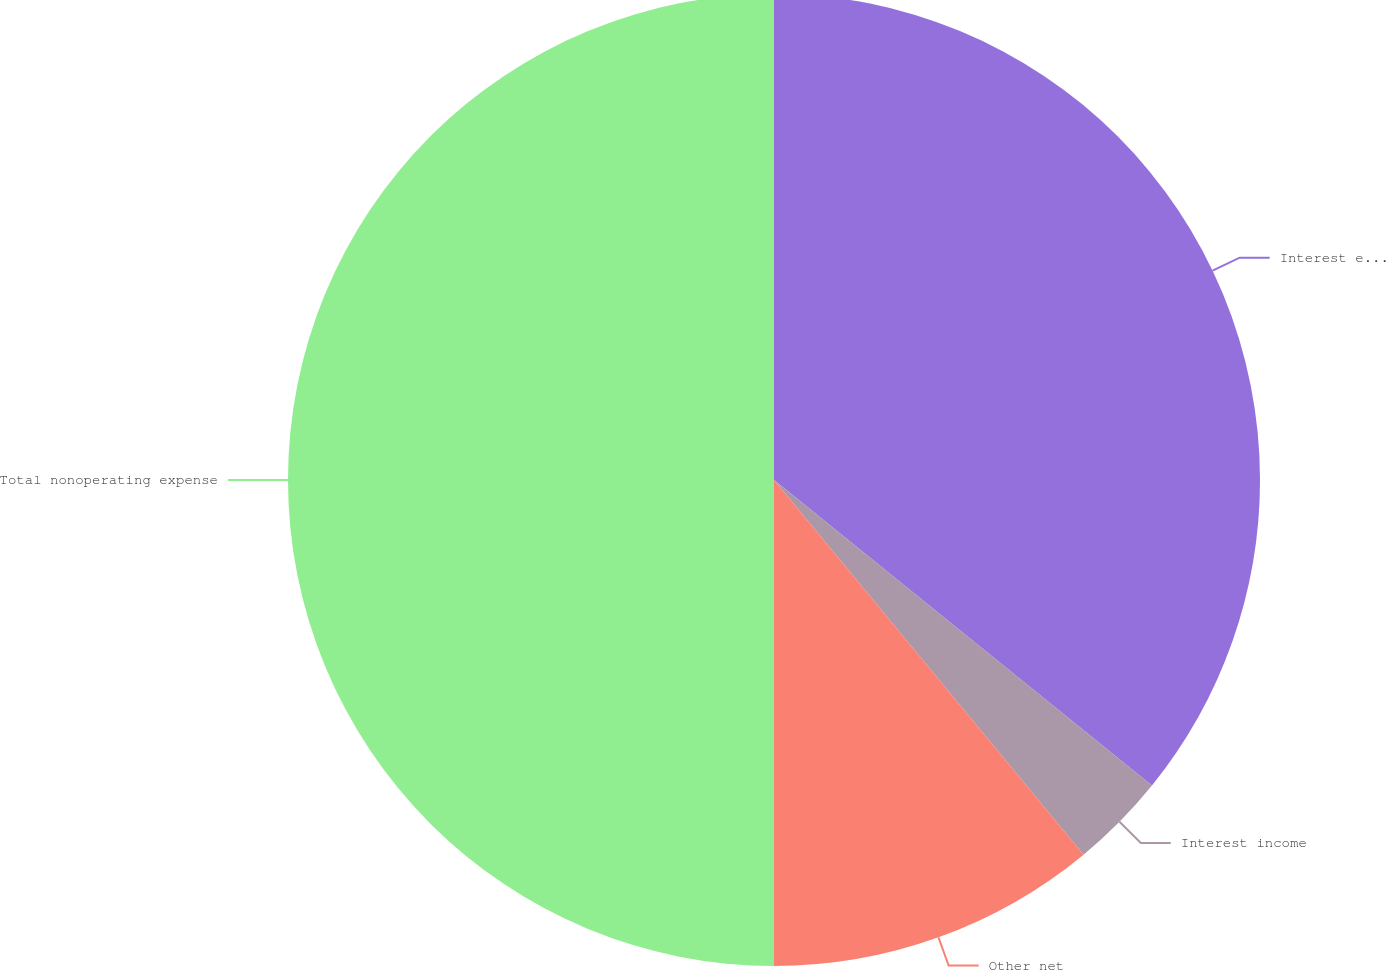Convert chart to OTSL. <chart><loc_0><loc_0><loc_500><loc_500><pie_chart><fcel>Interest expense<fcel>Interest income<fcel>Other net<fcel>Total nonoperating expense<nl><fcel>35.82%<fcel>3.19%<fcel>10.99%<fcel>50.0%<nl></chart> 